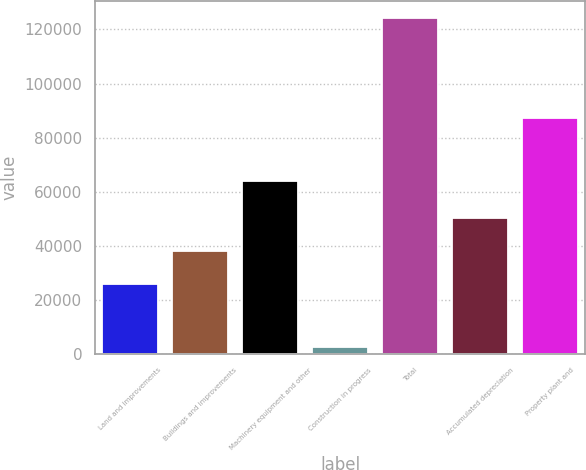Convert chart to OTSL. <chart><loc_0><loc_0><loc_500><loc_500><bar_chart><fcel>Land and improvements<fcel>Buildings and improvements<fcel>Machinery equipment and other<fcel>Construction in progress<fcel>Total<fcel>Accumulated depreciation<fcel>Property plant and<nl><fcel>25695<fcel>37888.4<fcel>64112<fcel>2454<fcel>124388<fcel>50081.8<fcel>87074<nl></chart> 